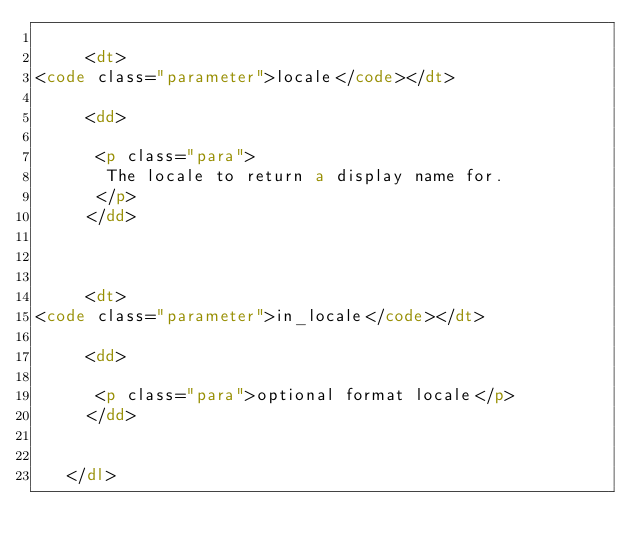<code> <loc_0><loc_0><loc_500><loc_500><_HTML_>    
     <dt>
<code class="parameter">locale</code></dt>

     <dd>

      <p class="para">
       The locale to return a display name for.
      </p>
     </dd>

    
    
     <dt>
<code class="parameter">in_locale</code></dt>

     <dd>

      <p class="para">optional format locale</p>
     </dd>

    
   </dl>
</code> 